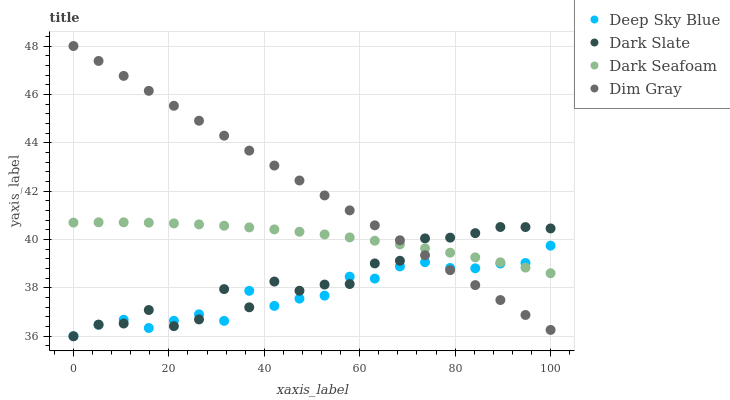Does Deep Sky Blue have the minimum area under the curve?
Answer yes or no. Yes. Does Dim Gray have the maximum area under the curve?
Answer yes or no. Yes. Does Dark Seafoam have the minimum area under the curve?
Answer yes or no. No. Does Dark Seafoam have the maximum area under the curve?
Answer yes or no. No. Is Dim Gray the smoothest?
Answer yes or no. Yes. Is Dark Slate the roughest?
Answer yes or no. Yes. Is Dark Seafoam the smoothest?
Answer yes or no. No. Is Dark Seafoam the roughest?
Answer yes or no. No. Does Dark Slate have the lowest value?
Answer yes or no. Yes. Does Dim Gray have the lowest value?
Answer yes or no. No. Does Dim Gray have the highest value?
Answer yes or no. Yes. Does Dark Seafoam have the highest value?
Answer yes or no. No. Does Deep Sky Blue intersect Dark Slate?
Answer yes or no. Yes. Is Deep Sky Blue less than Dark Slate?
Answer yes or no. No. Is Deep Sky Blue greater than Dark Slate?
Answer yes or no. No. 